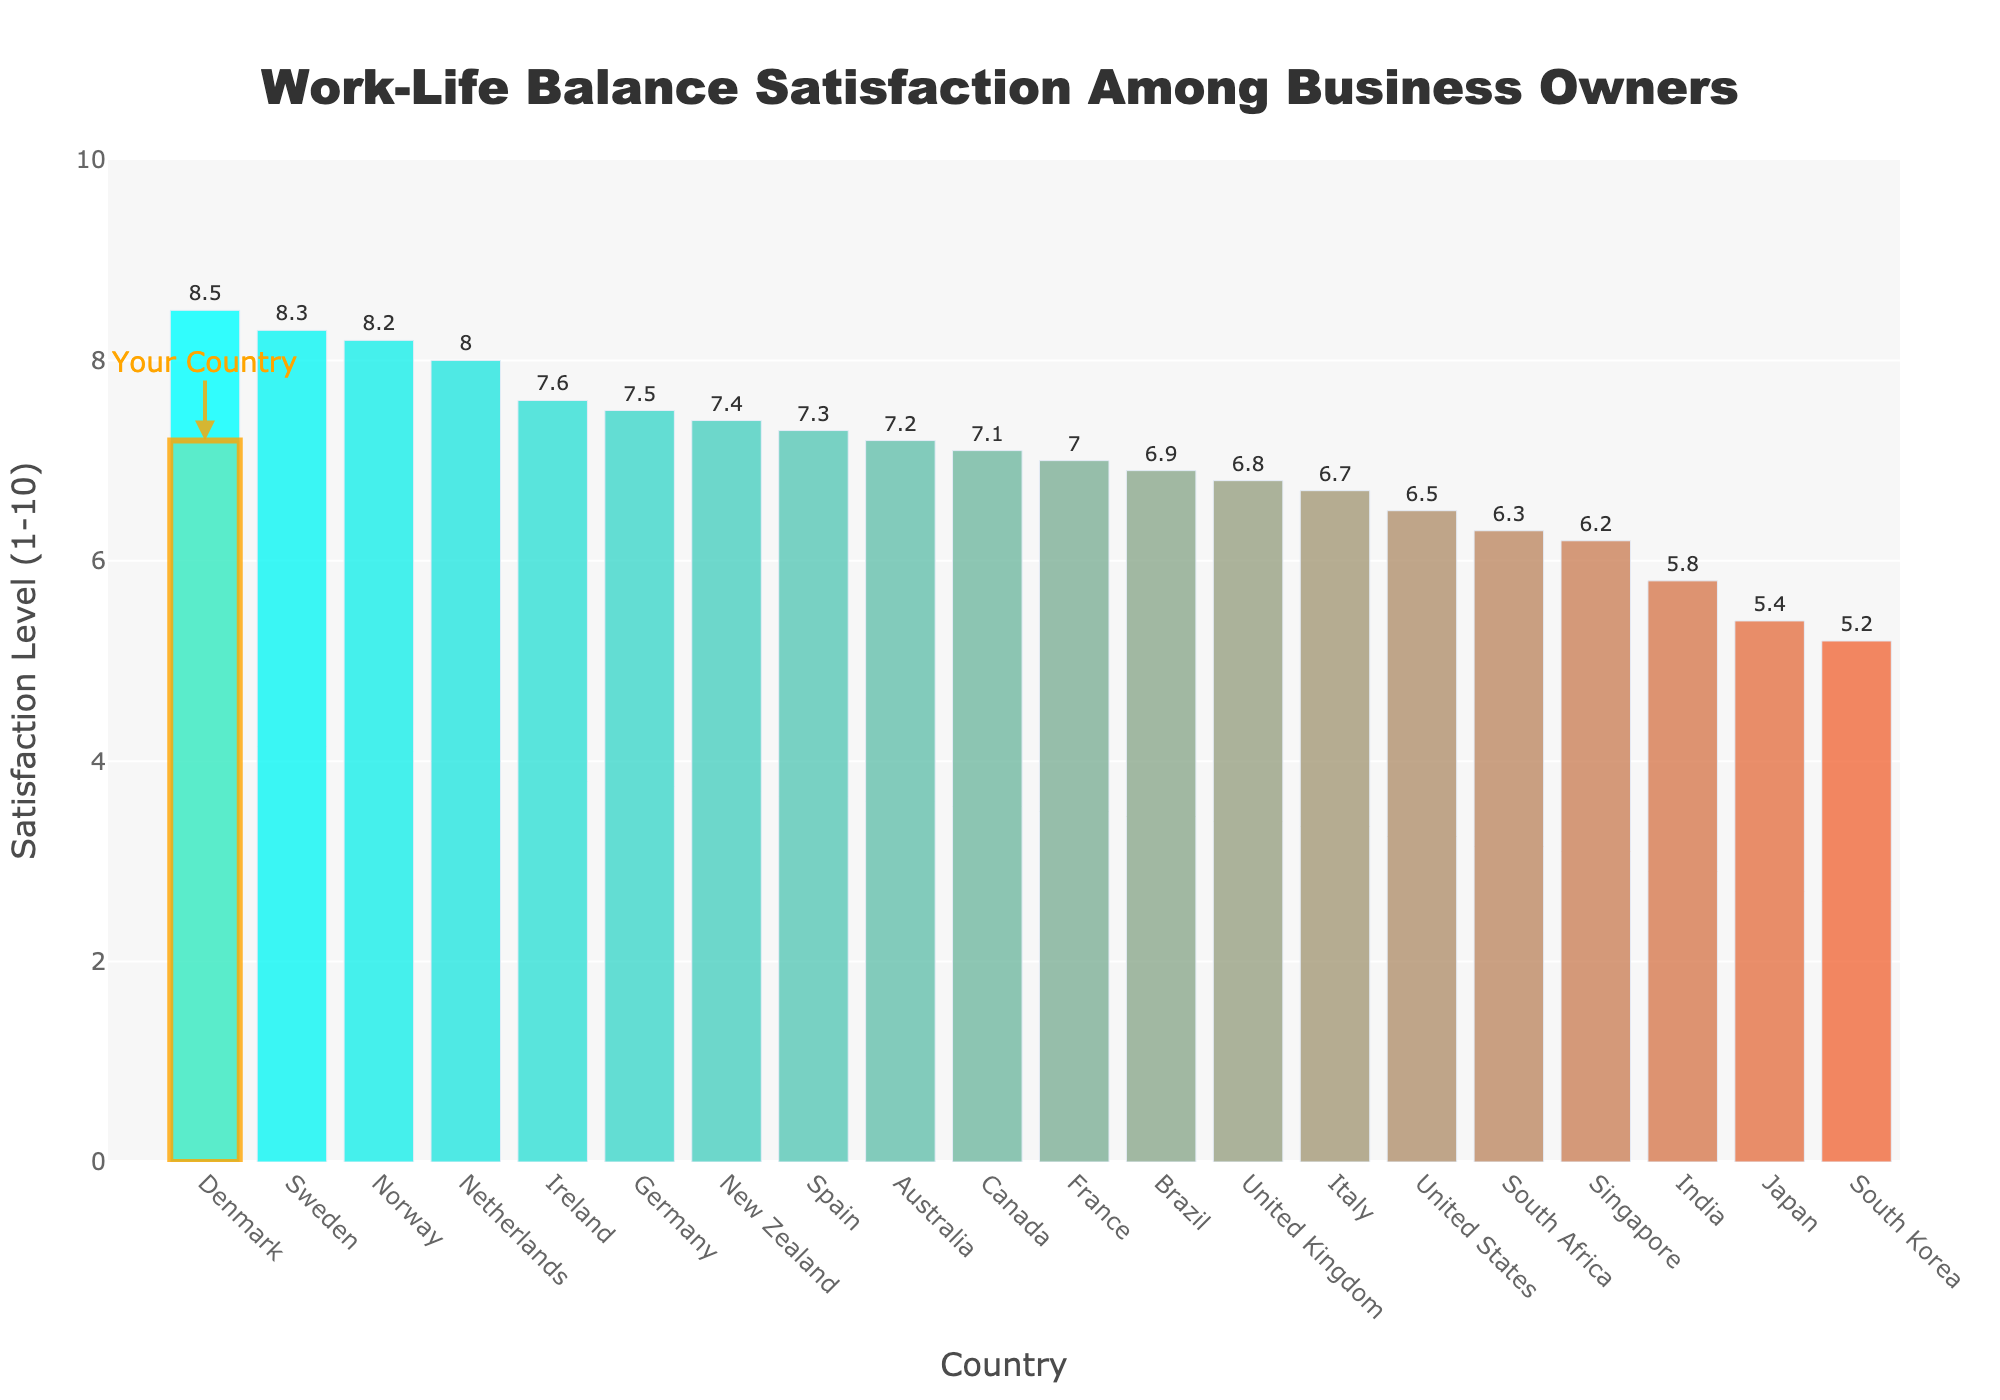What's the highest work-life balance satisfaction rating among the countries? From the bar chart, the highest work-life balance satisfaction rating can be identified by the tallest bar. The bar representing Denmark is the tallest.
Answer: Denmark Which country has the lowest work-life balance satisfaction rating? The country with the lowest satisfaction rating can be found by locating the shortest bar in the chart. South Korea has the shortest bar.
Answer: South Korea What is the difference in satisfaction ratings between Australia and the United States? From the chart, Australia's rating is 7.2 and the United States' rating is 6.5. Subtract the US rating from the Australian rating (7.2 - 6.5).
Answer: 0.7 How many countries have a satisfaction rating of 7.0 or higher? By counting the number of bars with a height of 7.0 or higher, we find that there are 12 such countries.
Answer: 12 Which countries have a higher work-life balance satisfaction rating than Australia? Identify bars that are taller than Australia's bar, specifically Denmark, Sweden, Netherlands, Norway, and Germany.
Answer: Denmark, Sweden, Netherlands, Norway, Germany What is the median work-life balance satisfaction rating? To find the median rating, list all ratings in ascending order: 5.2, 5.4, 5.8, 6.2, 6.3, 6.5, 6.7, 6.8, 6.9, 7.0, 7.1, 7.2, 7.3, 7.4, 7.5, 7.6, 8.0, 8.2, 8.3, 8.5. The middle value(s) in this list are 7.0 and 7.1, so the median is (7.0 + 7.1) / 2.
Answer: 7.05 Comparing Australia and Sweden, what's the difference in their satisfaction ratings? From the chart, Australia's rating is 7.2, and Sweden's rating is 8.3. Subtract Australia's rating from Sweden's rating (8.3 - 7.2).
Answer: 1.1 What is the average work-life balance satisfaction rating of all countries presented in the chart? First, sum all satisfaction ratings: 7.2+6.5+6.8+7.5+5.4+7.1+8.3+7+6.7+7.3+8+8.5+8.2+7.4+6.2+5.2+6.9+5.8+6.3+7.6 = 144.9. Then, divide by the total number of countries (20): 144.9 / 20.
Answer: 7.245 What is the combined work-life balance satisfaction rating for European countries listed in the chart? Sum the satisfaction ratings of the European countries: United Kingdom, Germany, Sweden, France, Italy, Spain, Netherlands, Denmark, and Norway. (6.8 + 7.5 + 8.3 + 7.0 + 6.7 + 7.3 + 8.0 + 8.5 + 8.2 = 68.3).
Answer: 68.3 Which countries have ratings equal to or below 6.0? Identify countries with ratings at or below 6.0: Japan, South Korea, India, and South Africa.
Answer: Japan, South Korea, India, South Africa 